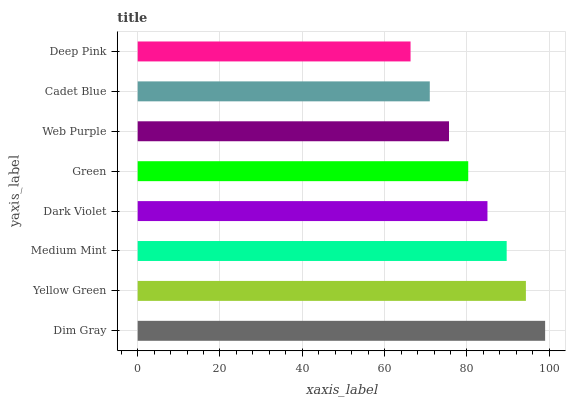Is Deep Pink the minimum?
Answer yes or no. Yes. Is Dim Gray the maximum?
Answer yes or no. Yes. Is Yellow Green the minimum?
Answer yes or no. No. Is Yellow Green the maximum?
Answer yes or no. No. Is Dim Gray greater than Yellow Green?
Answer yes or no. Yes. Is Yellow Green less than Dim Gray?
Answer yes or no. Yes. Is Yellow Green greater than Dim Gray?
Answer yes or no. No. Is Dim Gray less than Yellow Green?
Answer yes or no. No. Is Dark Violet the high median?
Answer yes or no. Yes. Is Green the low median?
Answer yes or no. Yes. Is Deep Pink the high median?
Answer yes or no. No. Is Deep Pink the low median?
Answer yes or no. No. 